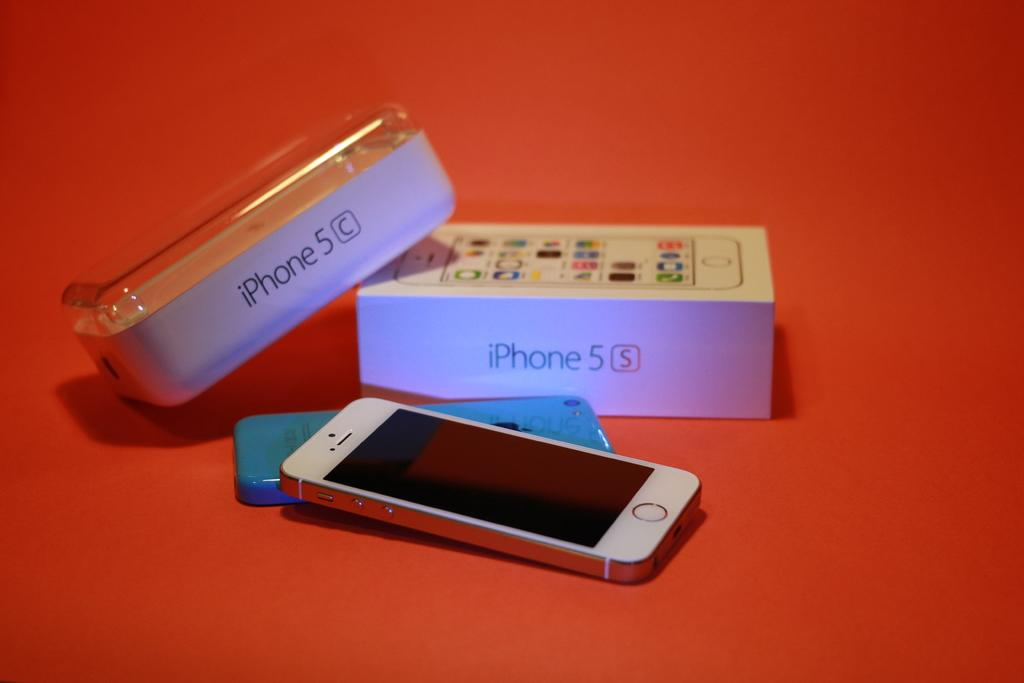Provide a one-sentence caption for the provided image. A case for an iPhone5, it is a white color. 